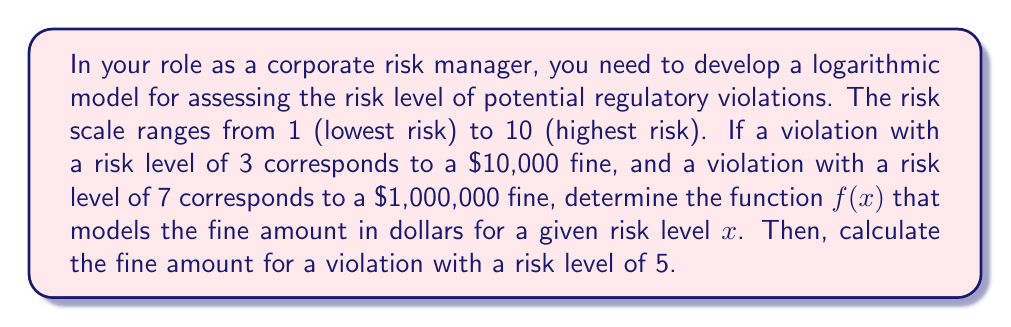Provide a solution to this math problem. 1) Let's use the general form of an exponential function: $f(x) = ab^x$, where $a$ and $b$ are constants we need to determine.

2) We have two points: (3, 10000) and (7, 1000000). Let's substitute these into our equation:

   10000 = $ab^3$
   1000000 = $ab^7$

3) Divide the second equation by the first:

   $\frac{1000000}{10000} = \frac{ab^7}{ab^3}$

4) Simplify:

   100 = $b^4$

5) Take the fourth root of both sides:

   $b = \sqrt[4]{100} = 3.16228$

6) Now substitute $b$ and (3, 10000) into the original equation:

   10000 = $a(3.16228)^3$

7) Solve for $a$:

   $a = \frac{10000}{(3.16228)^3} = 316.23$

8) Our function is therefore:

   $f(x) = 316.23 * (3.16228)^x$

9) To calculate the fine for a risk level of 5:

   $f(5) = 316.23 * (3.16228)^5 = 100000$
Answer: $f(x) = 316.23 * (3.16228)^x$; $100,000 